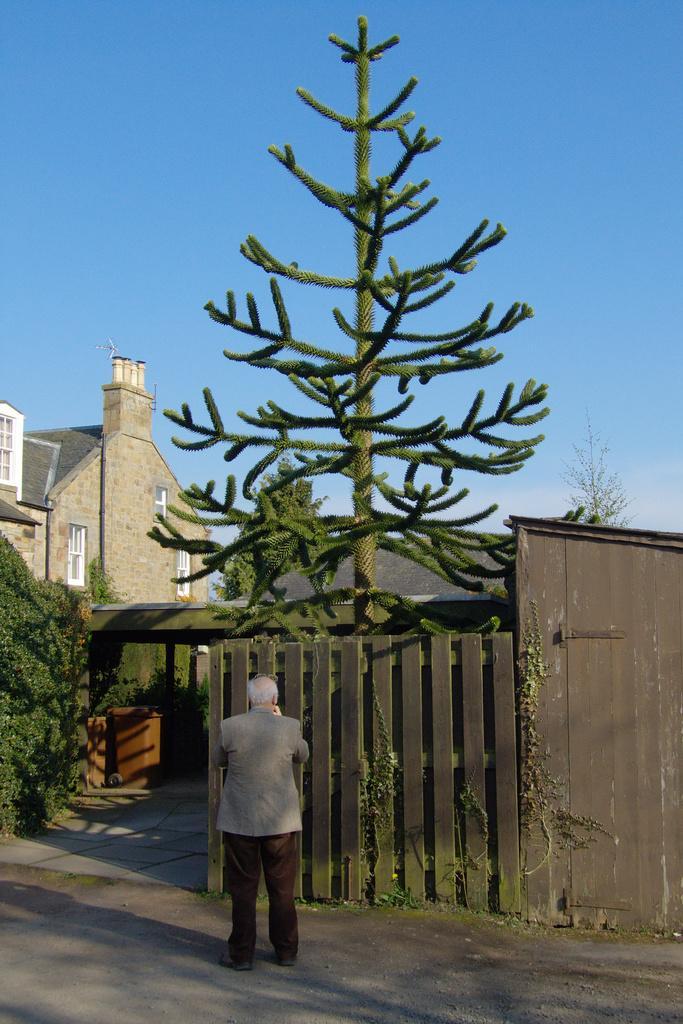In one or two sentences, can you explain what this image depicts? In this image there is the sky towards the top of the image, there is a building towards the left of the image, there are windows, there is a wall towards the right of the image, there is a tree, there are plants towards the left of the image, there is a man standing, there is road towards the bottom of the image. 